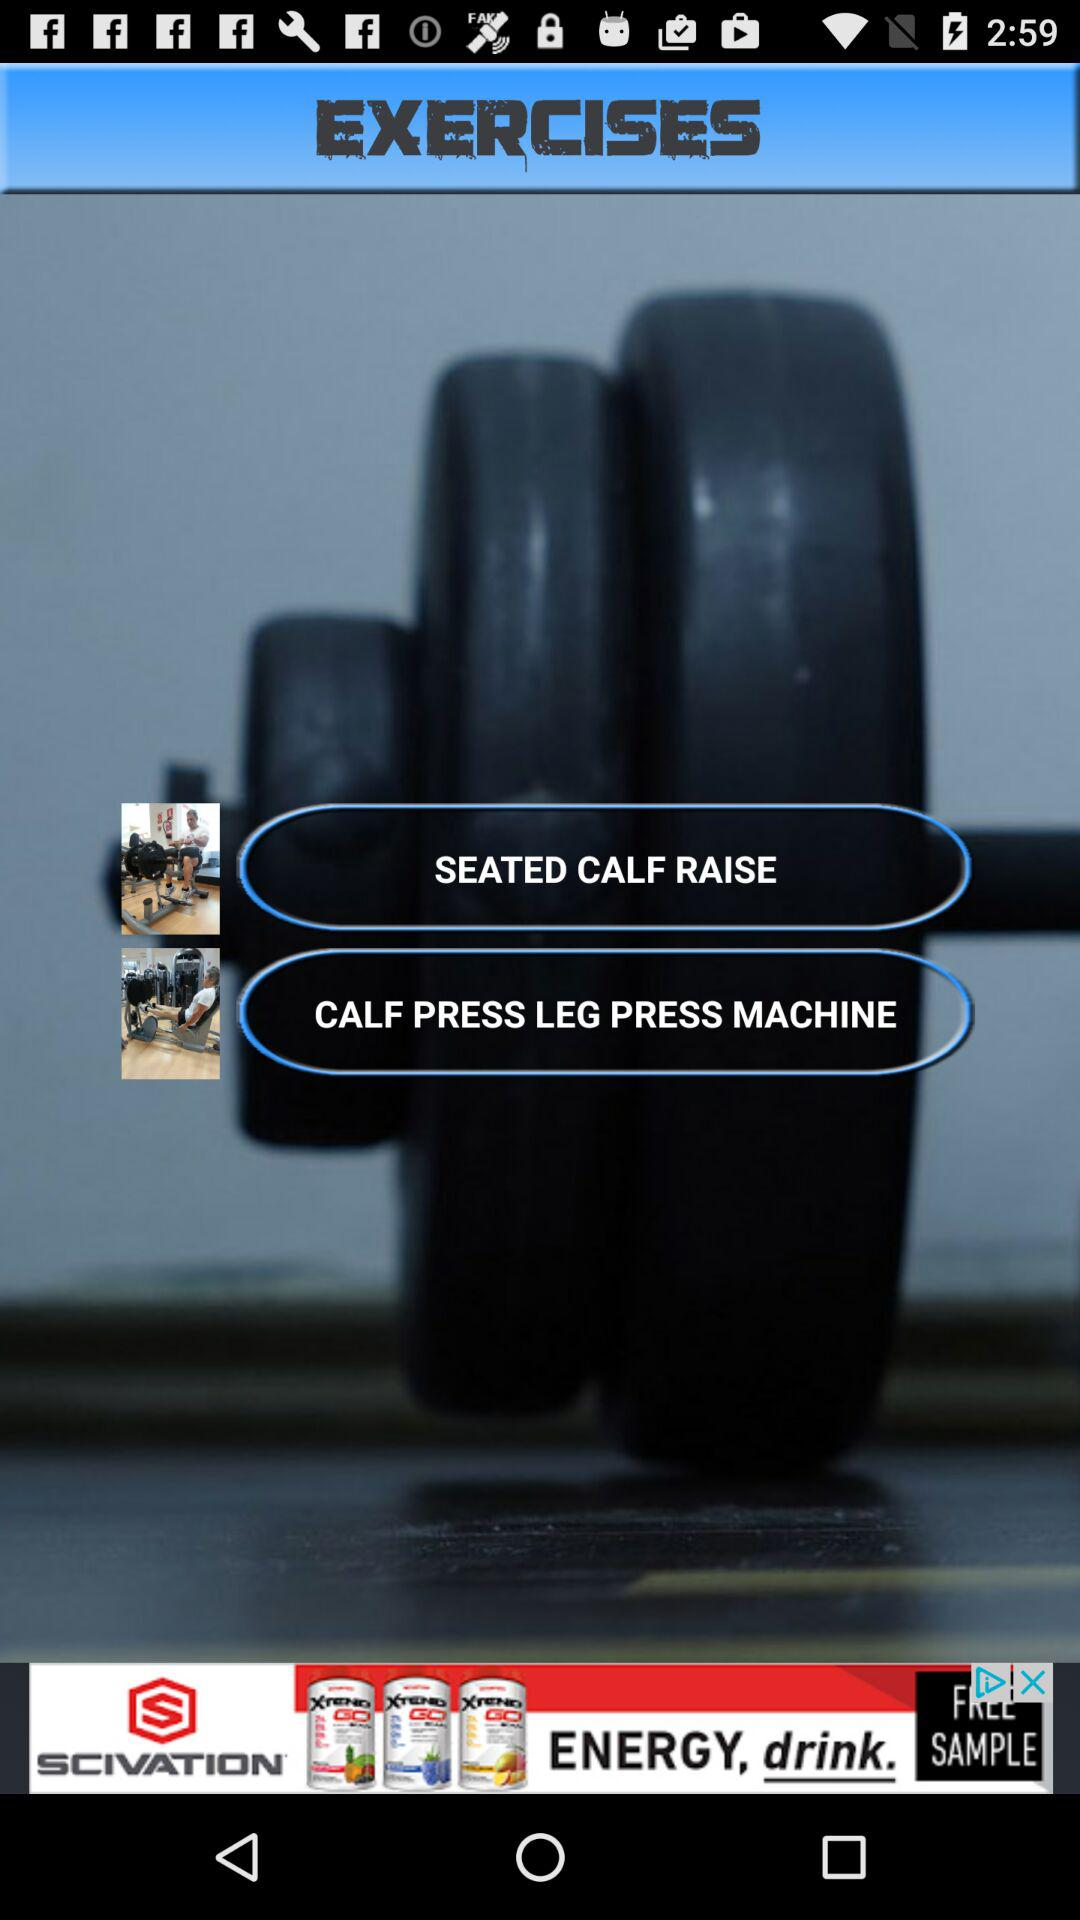Which are the different exercises? The different exercise are "SEATED CALF RAISE" and "CALF PRESS". 